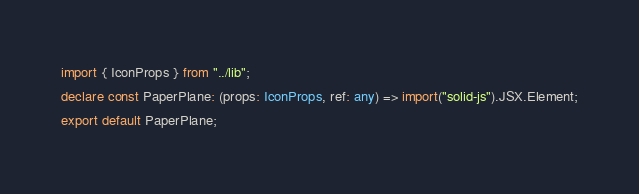Convert code to text. <code><loc_0><loc_0><loc_500><loc_500><_TypeScript_>import { IconProps } from "../lib";
declare const PaperPlane: (props: IconProps, ref: any) => import("solid-js").JSX.Element;
export default PaperPlane;
</code> 